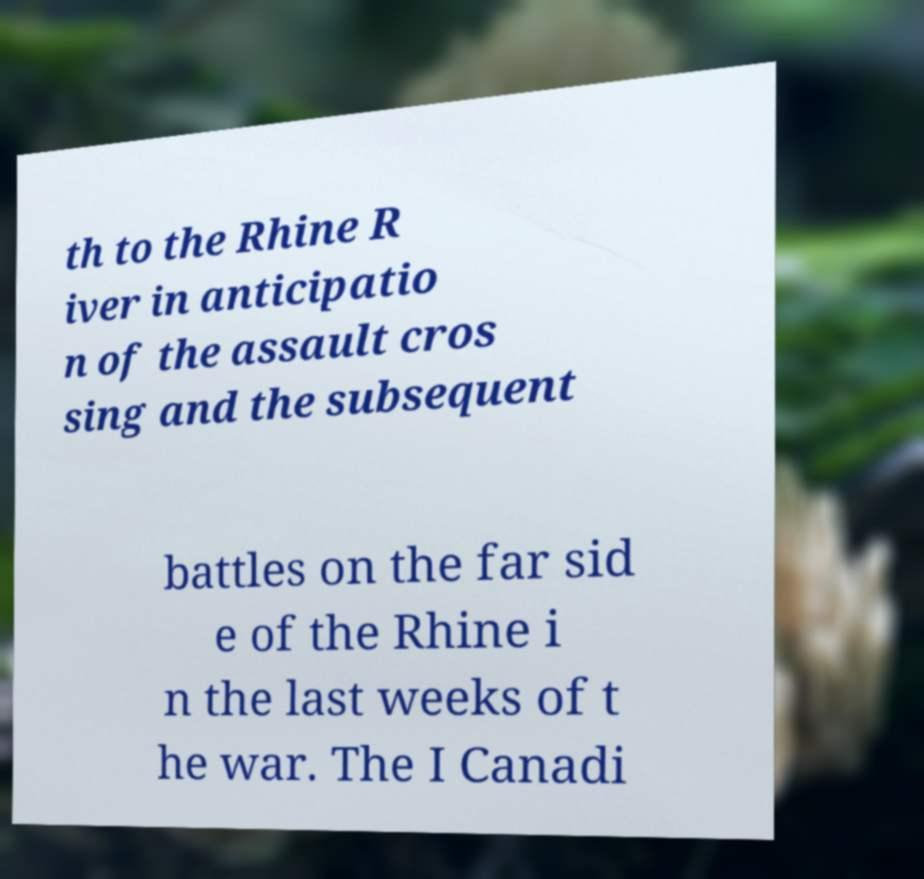There's text embedded in this image that I need extracted. Can you transcribe it verbatim? th to the Rhine R iver in anticipatio n of the assault cros sing and the subsequent battles on the far sid e of the Rhine i n the last weeks of t he war. The I Canadi 